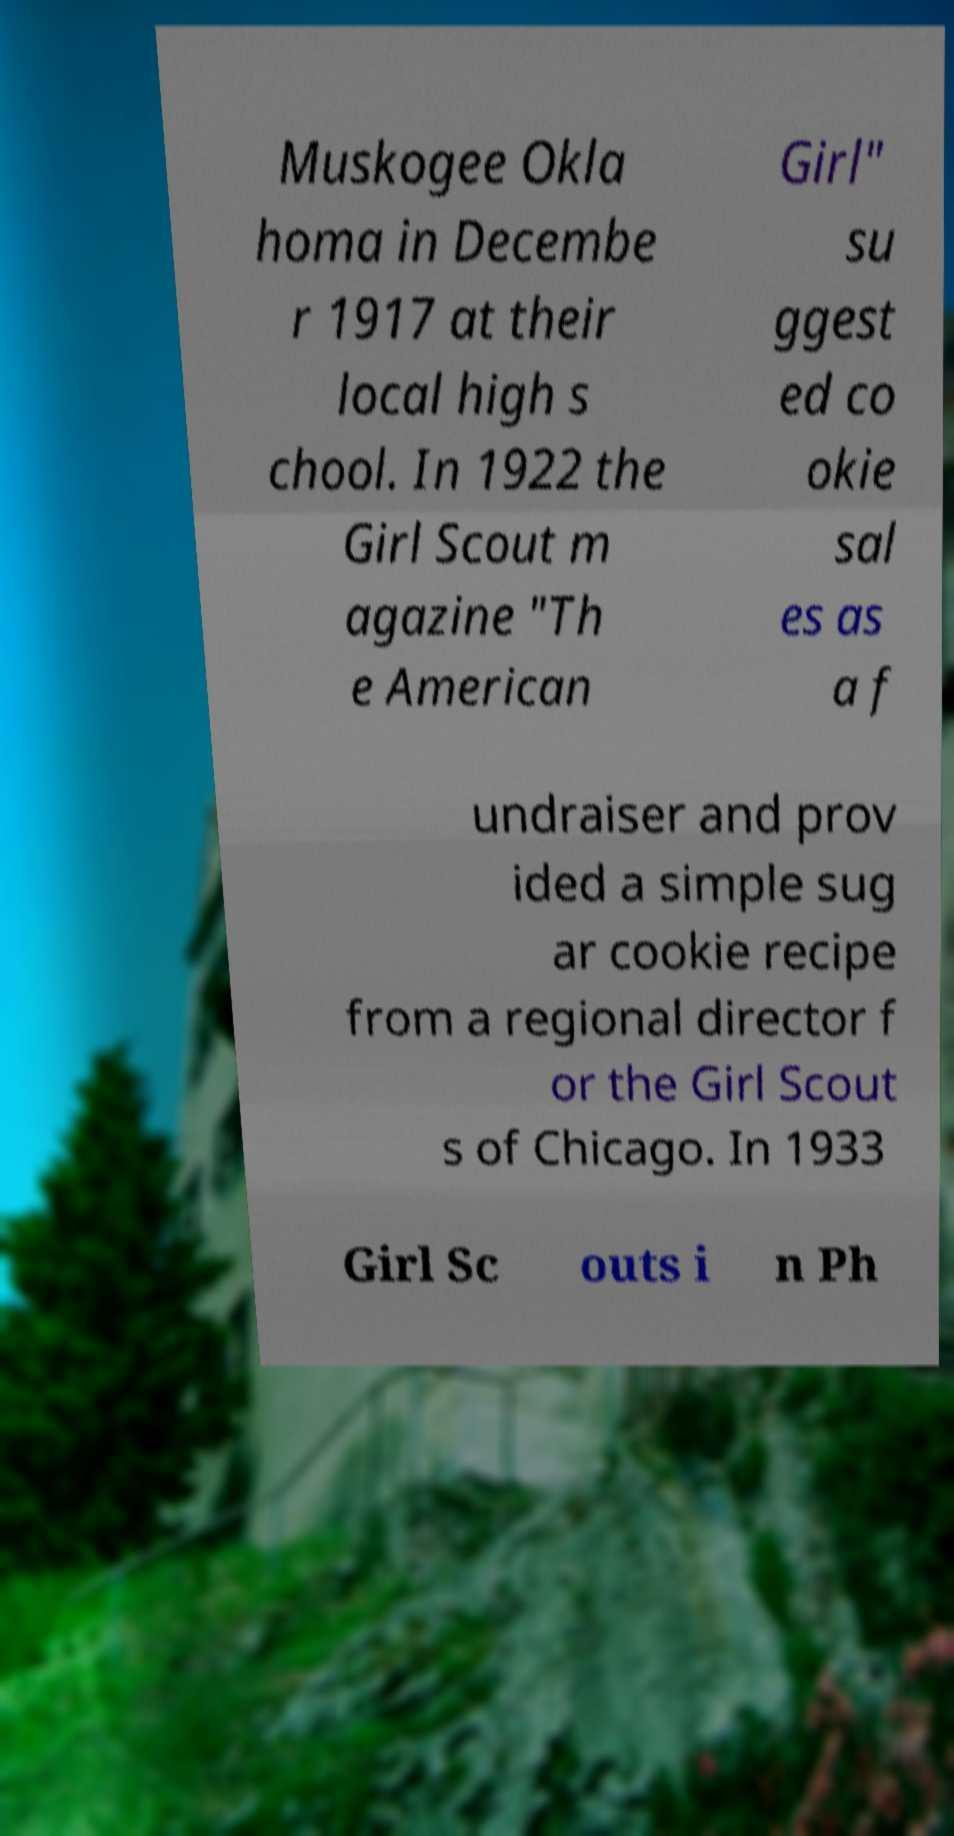Can you read and provide the text displayed in the image?This photo seems to have some interesting text. Can you extract and type it out for me? Muskogee Okla homa in Decembe r 1917 at their local high s chool. In 1922 the Girl Scout m agazine "Th e American Girl" su ggest ed co okie sal es as a f undraiser and prov ided a simple sug ar cookie recipe from a regional director f or the Girl Scout s of Chicago. In 1933 Girl Sc outs i n Ph 